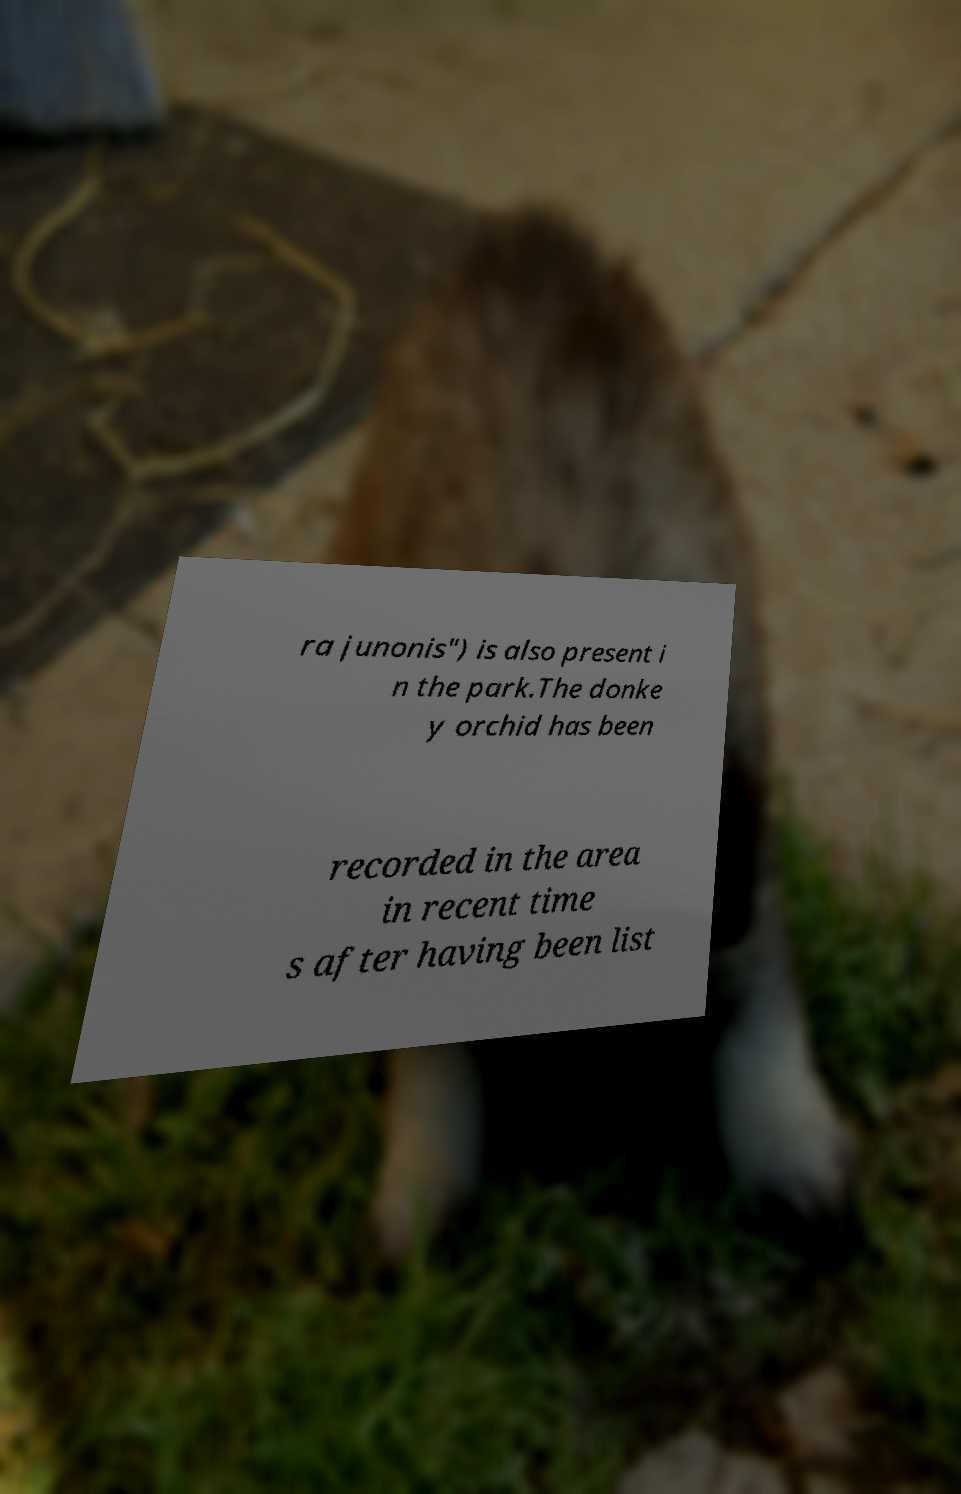Can you accurately transcribe the text from the provided image for me? ra junonis") is also present i n the park.The donke y orchid has been recorded in the area in recent time s after having been list 